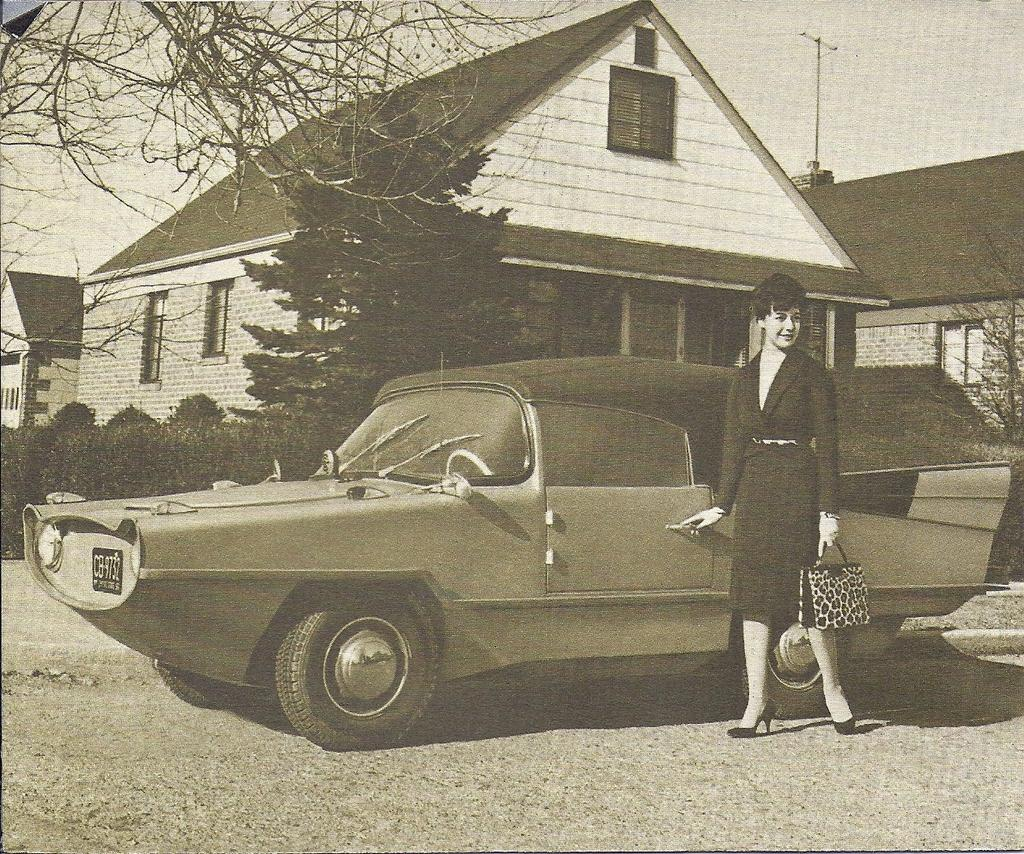What is the main subject in the middle of the picture? There is a car in the middle of the picture. Who is standing beside the car? There is a woman standing beside the car. Where is the woman standing? The woman is standing on the land. What can be seen in the background of the picture? There are houses, trees, and the sky visible in the background of the picture. What type of beam is holding up the car in the image? There is no beam holding up the car in the image; it is resting on the ground. What flavor of soda is the woman holding in the image? There is no soda present in the image; the woman is not holding any beverage. 